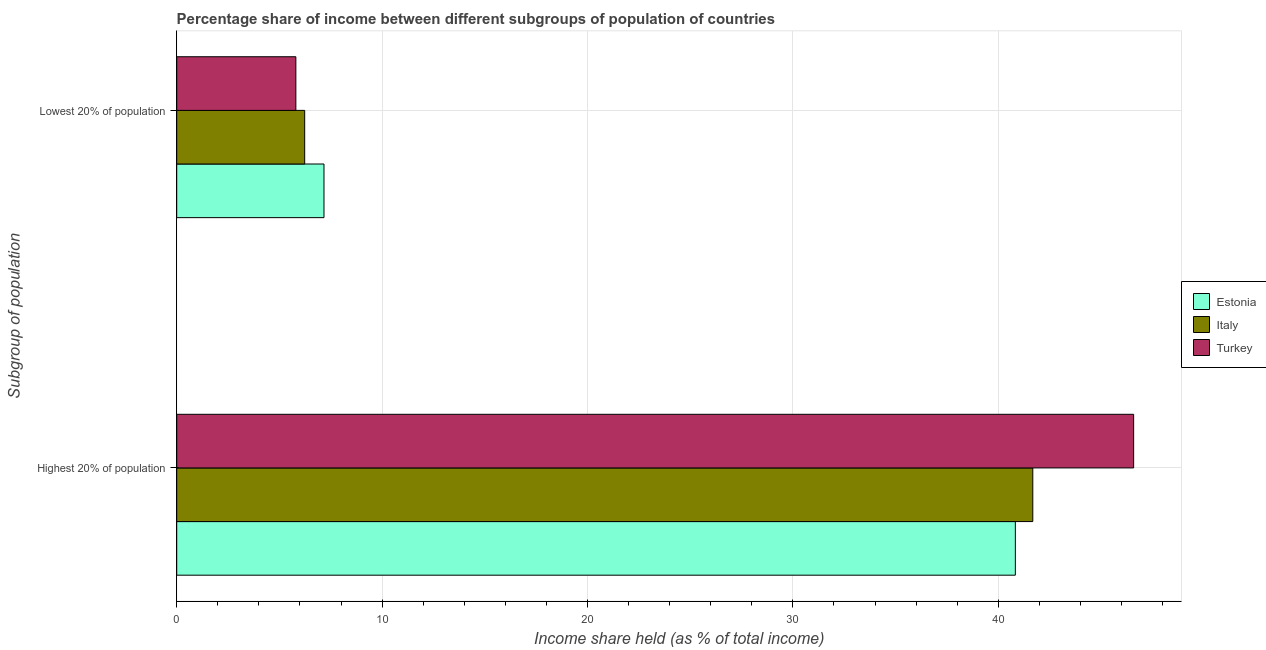How many different coloured bars are there?
Provide a short and direct response. 3. How many groups of bars are there?
Ensure brevity in your answer.  2. Are the number of bars on each tick of the Y-axis equal?
Your answer should be compact. Yes. How many bars are there on the 1st tick from the bottom?
Your response must be concise. 3. What is the label of the 1st group of bars from the top?
Your answer should be very brief. Lowest 20% of population. What is the income share held by highest 20% of the population in Turkey?
Your answer should be compact. 46.59. Across all countries, what is the maximum income share held by highest 20% of the population?
Your answer should be very brief. 46.59. Across all countries, what is the minimum income share held by lowest 20% of the population?
Your answer should be compact. 5.8. What is the total income share held by highest 20% of the population in the graph?
Provide a short and direct response. 129.1. What is the difference between the income share held by lowest 20% of the population in Italy and that in Turkey?
Make the answer very short. 0.43. What is the difference between the income share held by highest 20% of the population in Turkey and the income share held by lowest 20% of the population in Estonia?
Make the answer very short. 39.42. What is the average income share held by lowest 20% of the population per country?
Offer a terse response. 6.4. What is the difference between the income share held by lowest 20% of the population and income share held by highest 20% of the population in Italy?
Ensure brevity in your answer.  -35.45. In how many countries, is the income share held by lowest 20% of the population greater than 38 %?
Provide a short and direct response. 0. What is the ratio of the income share held by lowest 20% of the population in Turkey to that in Estonia?
Keep it short and to the point. 0.81. What does the 3rd bar from the top in Lowest 20% of population represents?
Make the answer very short. Estonia. What does the 3rd bar from the bottom in Highest 20% of population represents?
Ensure brevity in your answer.  Turkey. How many bars are there?
Offer a very short reply. 6. Are all the bars in the graph horizontal?
Your answer should be compact. Yes. How many countries are there in the graph?
Ensure brevity in your answer.  3. What is the difference between two consecutive major ticks on the X-axis?
Give a very brief answer. 10. Are the values on the major ticks of X-axis written in scientific E-notation?
Provide a short and direct response. No. Does the graph contain any zero values?
Provide a succinct answer. No. Does the graph contain grids?
Provide a succinct answer. Yes. How many legend labels are there?
Your answer should be very brief. 3. What is the title of the graph?
Your response must be concise. Percentage share of income between different subgroups of population of countries. What is the label or title of the X-axis?
Provide a short and direct response. Income share held (as % of total income). What is the label or title of the Y-axis?
Provide a short and direct response. Subgroup of population. What is the Income share held (as % of total income) of Estonia in Highest 20% of population?
Keep it short and to the point. 40.83. What is the Income share held (as % of total income) of Italy in Highest 20% of population?
Provide a short and direct response. 41.68. What is the Income share held (as % of total income) in Turkey in Highest 20% of population?
Ensure brevity in your answer.  46.59. What is the Income share held (as % of total income) of Estonia in Lowest 20% of population?
Your response must be concise. 7.17. What is the Income share held (as % of total income) of Italy in Lowest 20% of population?
Offer a terse response. 6.23. What is the Income share held (as % of total income) of Turkey in Lowest 20% of population?
Keep it short and to the point. 5.8. Across all Subgroup of population, what is the maximum Income share held (as % of total income) in Estonia?
Give a very brief answer. 40.83. Across all Subgroup of population, what is the maximum Income share held (as % of total income) of Italy?
Offer a very short reply. 41.68. Across all Subgroup of population, what is the maximum Income share held (as % of total income) of Turkey?
Your answer should be very brief. 46.59. Across all Subgroup of population, what is the minimum Income share held (as % of total income) in Estonia?
Your answer should be very brief. 7.17. Across all Subgroup of population, what is the minimum Income share held (as % of total income) of Italy?
Give a very brief answer. 6.23. What is the total Income share held (as % of total income) in Estonia in the graph?
Offer a terse response. 48. What is the total Income share held (as % of total income) in Italy in the graph?
Give a very brief answer. 47.91. What is the total Income share held (as % of total income) in Turkey in the graph?
Offer a very short reply. 52.39. What is the difference between the Income share held (as % of total income) in Estonia in Highest 20% of population and that in Lowest 20% of population?
Your response must be concise. 33.66. What is the difference between the Income share held (as % of total income) of Italy in Highest 20% of population and that in Lowest 20% of population?
Keep it short and to the point. 35.45. What is the difference between the Income share held (as % of total income) of Turkey in Highest 20% of population and that in Lowest 20% of population?
Provide a succinct answer. 40.79. What is the difference between the Income share held (as % of total income) in Estonia in Highest 20% of population and the Income share held (as % of total income) in Italy in Lowest 20% of population?
Provide a short and direct response. 34.6. What is the difference between the Income share held (as % of total income) in Estonia in Highest 20% of population and the Income share held (as % of total income) in Turkey in Lowest 20% of population?
Offer a terse response. 35.03. What is the difference between the Income share held (as % of total income) of Italy in Highest 20% of population and the Income share held (as % of total income) of Turkey in Lowest 20% of population?
Provide a short and direct response. 35.88. What is the average Income share held (as % of total income) in Italy per Subgroup of population?
Ensure brevity in your answer.  23.95. What is the average Income share held (as % of total income) in Turkey per Subgroup of population?
Offer a terse response. 26.2. What is the difference between the Income share held (as % of total income) of Estonia and Income share held (as % of total income) of Italy in Highest 20% of population?
Your response must be concise. -0.85. What is the difference between the Income share held (as % of total income) of Estonia and Income share held (as % of total income) of Turkey in Highest 20% of population?
Provide a succinct answer. -5.76. What is the difference between the Income share held (as % of total income) of Italy and Income share held (as % of total income) of Turkey in Highest 20% of population?
Provide a short and direct response. -4.91. What is the difference between the Income share held (as % of total income) in Estonia and Income share held (as % of total income) in Italy in Lowest 20% of population?
Offer a very short reply. 0.94. What is the difference between the Income share held (as % of total income) of Estonia and Income share held (as % of total income) of Turkey in Lowest 20% of population?
Keep it short and to the point. 1.37. What is the difference between the Income share held (as % of total income) of Italy and Income share held (as % of total income) of Turkey in Lowest 20% of population?
Make the answer very short. 0.43. What is the ratio of the Income share held (as % of total income) of Estonia in Highest 20% of population to that in Lowest 20% of population?
Provide a succinct answer. 5.69. What is the ratio of the Income share held (as % of total income) of Italy in Highest 20% of population to that in Lowest 20% of population?
Your response must be concise. 6.69. What is the ratio of the Income share held (as % of total income) of Turkey in Highest 20% of population to that in Lowest 20% of population?
Your answer should be compact. 8.03. What is the difference between the highest and the second highest Income share held (as % of total income) of Estonia?
Your answer should be compact. 33.66. What is the difference between the highest and the second highest Income share held (as % of total income) of Italy?
Provide a short and direct response. 35.45. What is the difference between the highest and the second highest Income share held (as % of total income) in Turkey?
Ensure brevity in your answer.  40.79. What is the difference between the highest and the lowest Income share held (as % of total income) in Estonia?
Ensure brevity in your answer.  33.66. What is the difference between the highest and the lowest Income share held (as % of total income) in Italy?
Your answer should be very brief. 35.45. What is the difference between the highest and the lowest Income share held (as % of total income) in Turkey?
Make the answer very short. 40.79. 